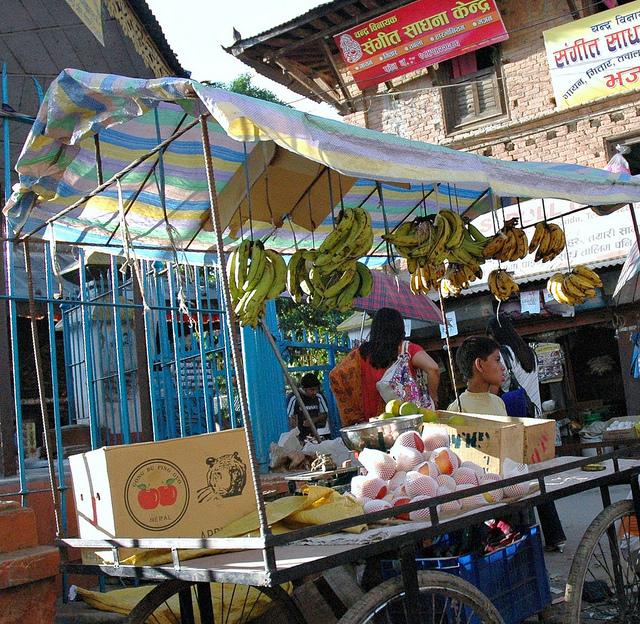What is the roof of the cart made of?
Give a very brief answer. Fabric. What does the sign say?
Quick response, please. Fruits. What animal is shown on the box on the left?
Short answer required. Tiger. What number or colorful cages are there in this scene?
Concise answer only. 1. Are these bananas ripe?
Keep it brief. Yes. 